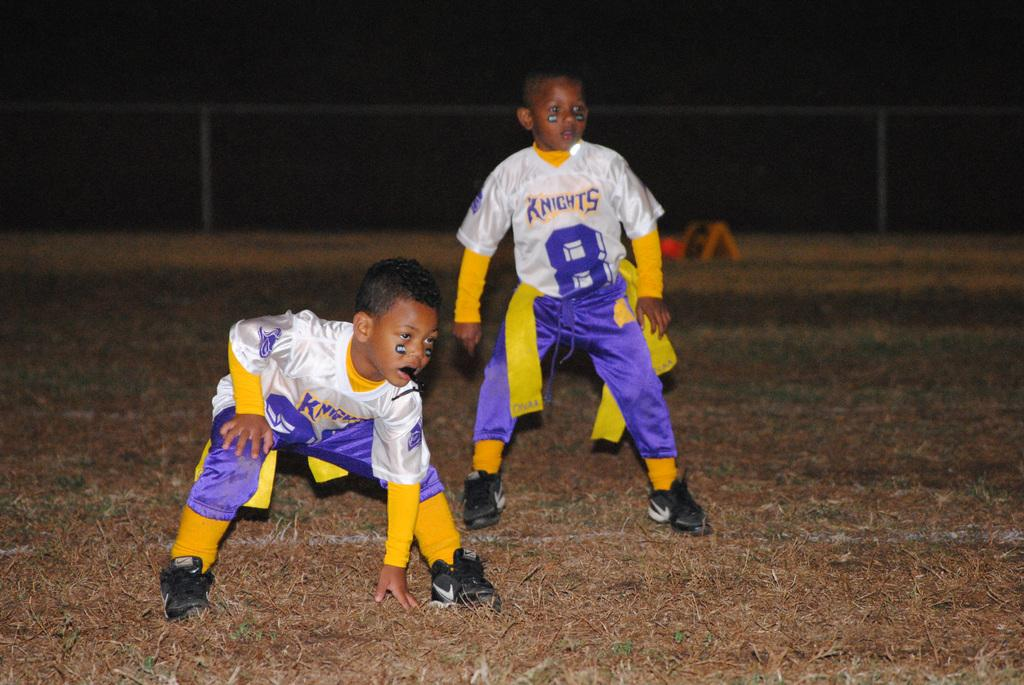<image>
Summarize the visual content of the image. Two little boys playing flag football in Knights jerseys. 